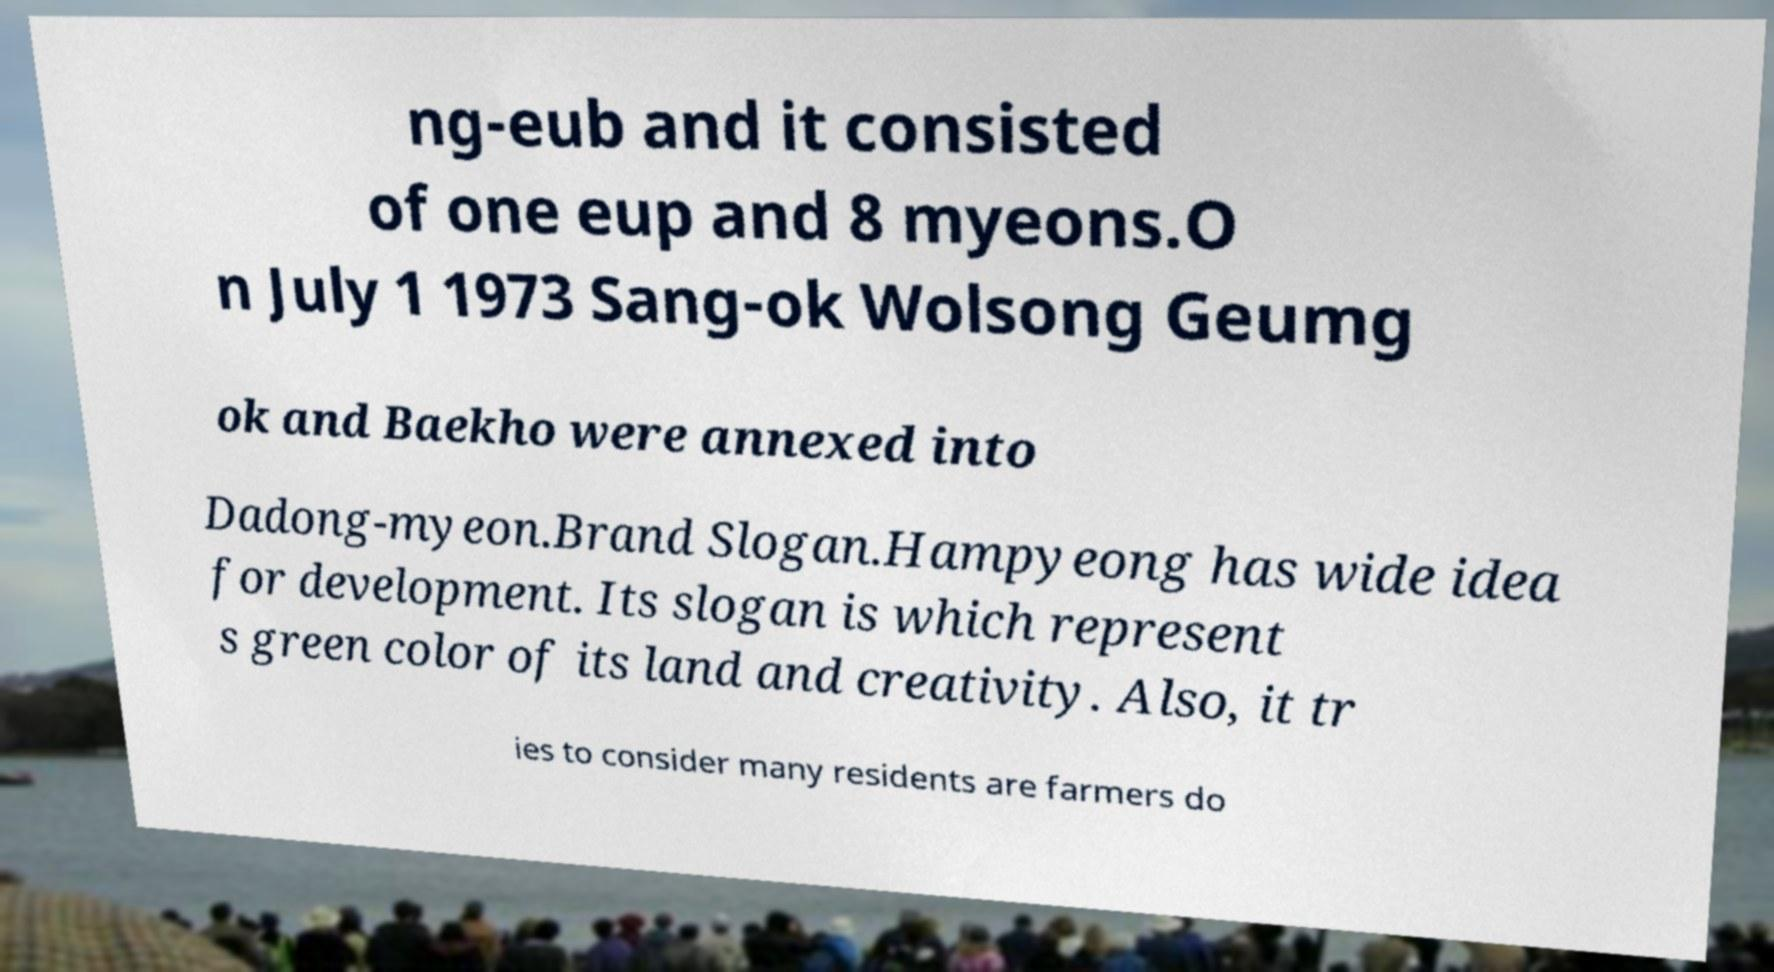Please read and relay the text visible in this image. What does it say? ng-eub and it consisted of one eup and 8 myeons.O n July 1 1973 Sang-ok Wolsong Geumg ok and Baekho were annexed into Dadong-myeon.Brand Slogan.Hampyeong has wide idea for development. Its slogan is which represent s green color of its land and creativity. Also, it tr ies to consider many residents are farmers do 